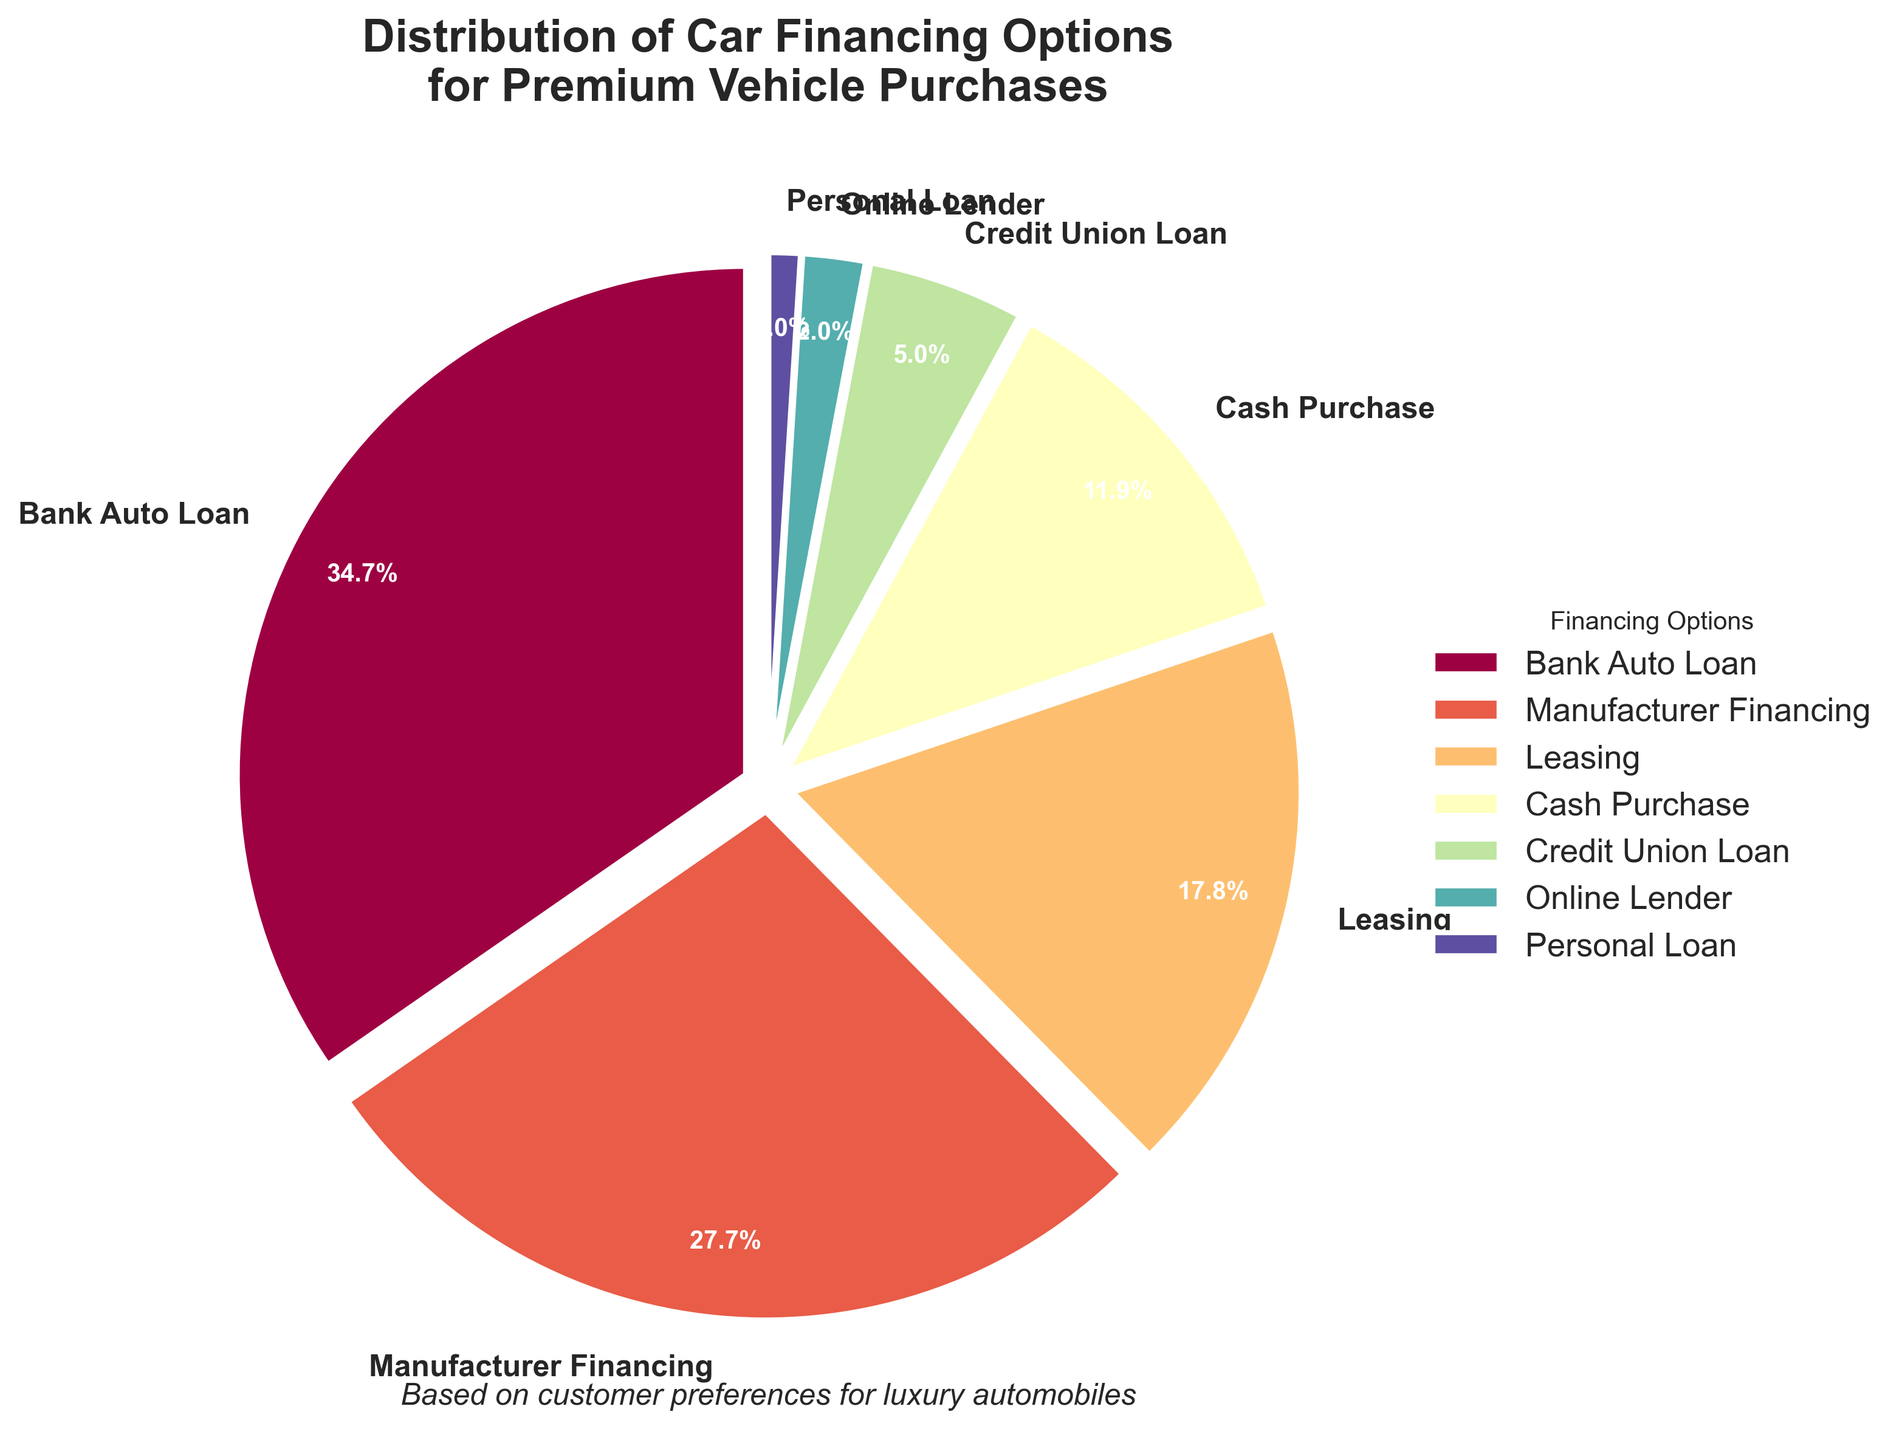Which financing option has the highest percentage? The largest slice in the pie chart represents the financing option with the highest percentage. The label corresponding to this slice indicates "Bank Auto Loan" with 35%.
Answer: Bank Auto Loan Which financing option has the smallest percentage? The smallest slice in the pie chart represents the financing option with the smallest percentage. The label corresponding to this slice indicates "Personal Loan" with 1%.
Answer: Personal Loan What is the combined percentage of Leasing and Cash Purchase? To find the combined percentage, add the percentages for Leasing (18%) and Cash Purchase (12%). 18% + 12% = 30%.
Answer: 30% How much more popular is Bank Auto Loan compared to Manufacturer Financing? Bank Auto Loan has a percentage of 35%, and Manufacturer Financing has 28%. The difference is 35% - 28% = 7%.
Answer: 7% Which two financing options combined make up less than 10% of the total? The percentages for Credit Union Loan, Online Lender, and Personal Loan are 5%, 2%, and 1%, respectively. Since 2% + 1% = 3%, which is less than 10%, Online Lender and Personal Loan together make up less than 10%.
Answer: Online Lender and Personal Loan If we group Bank Auto Loan and Manufacturer Financing together, what percentage of the total do they account for? Add the percentages for Bank Auto Loan (35%) and Manufacturer Financing (28%). 35% + 28% = 63%.
Answer: 63% What is the third most popular financing option? From the pie chart, the percentages in decreasing order are Bank Auto Loan (35%), Manufacturer Financing (28%), Leasing (18%), and Cash Purchase (12%). The third most popular is Leasing with 18%.
Answer: Leasing Is the percentage of Manufacturer Financing greater than the combined percentage of Cash Purchase and Leasing? Manufacturer Financing is 28%, and the combined percentage of Cash Purchase (12%) and Leasing (18%) is 12% + 18% = 30%. 28% is less than 30%.
Answer: No Which financing option is represented by the most prominent color in the pie chart? The largest slice, which is Bank Auto Loan, is also at the start of the color gradient and will typically have the most prominent color.
Answer: Bank Auto Loan What is the percentage difference between Credit Union Loan and Online Lender? Credit Union Loan is 5%, and Online Lender is 2%. The difference is 5% - 2% = 3%.
Answer: 3% 